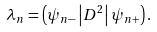<formula> <loc_0><loc_0><loc_500><loc_500>\lambda _ { n } = \left ( \psi _ { n - } \left | D ^ { 2 } \right | \psi _ { n + } \right ) .</formula> 